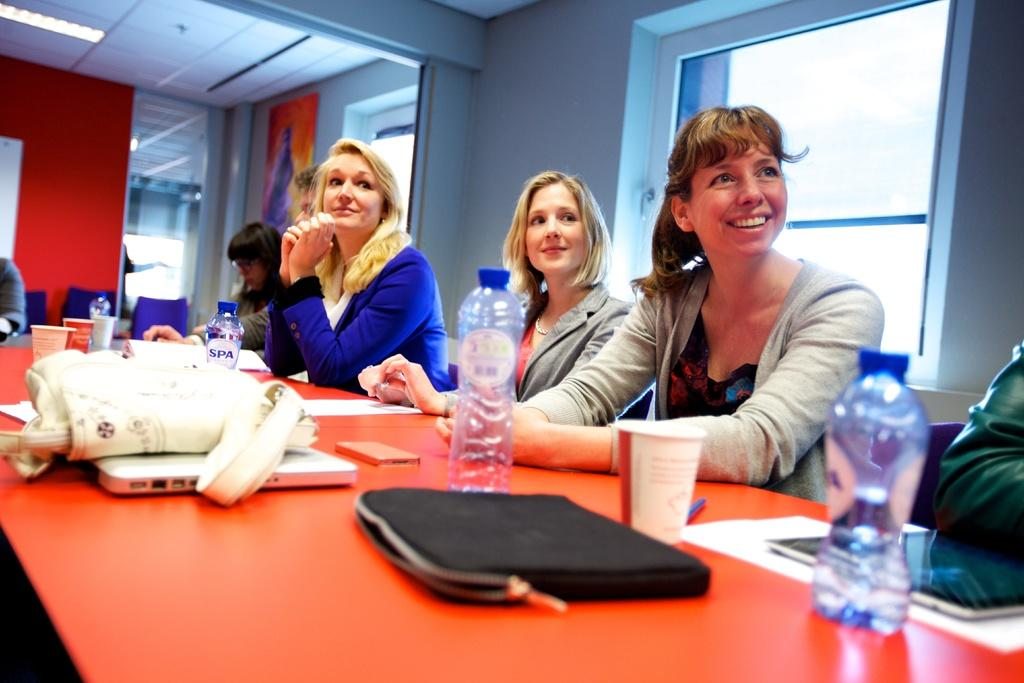How many people are sitting in the image? There are four people sitting in the image: three women and one man. What objects can be seen on the table in the image? There are bottles, glasses, a bag, and a laptop on the table in the image. What is visible in the background of the image? There is a window and a wall in the background of the image. What type of fruit is being used as a pocket in the image? There is no fruit or pocket present in the image. Who is the achiever in the image? The provided facts do not mention any achievements or individuals being recognized for their accomplishments. 